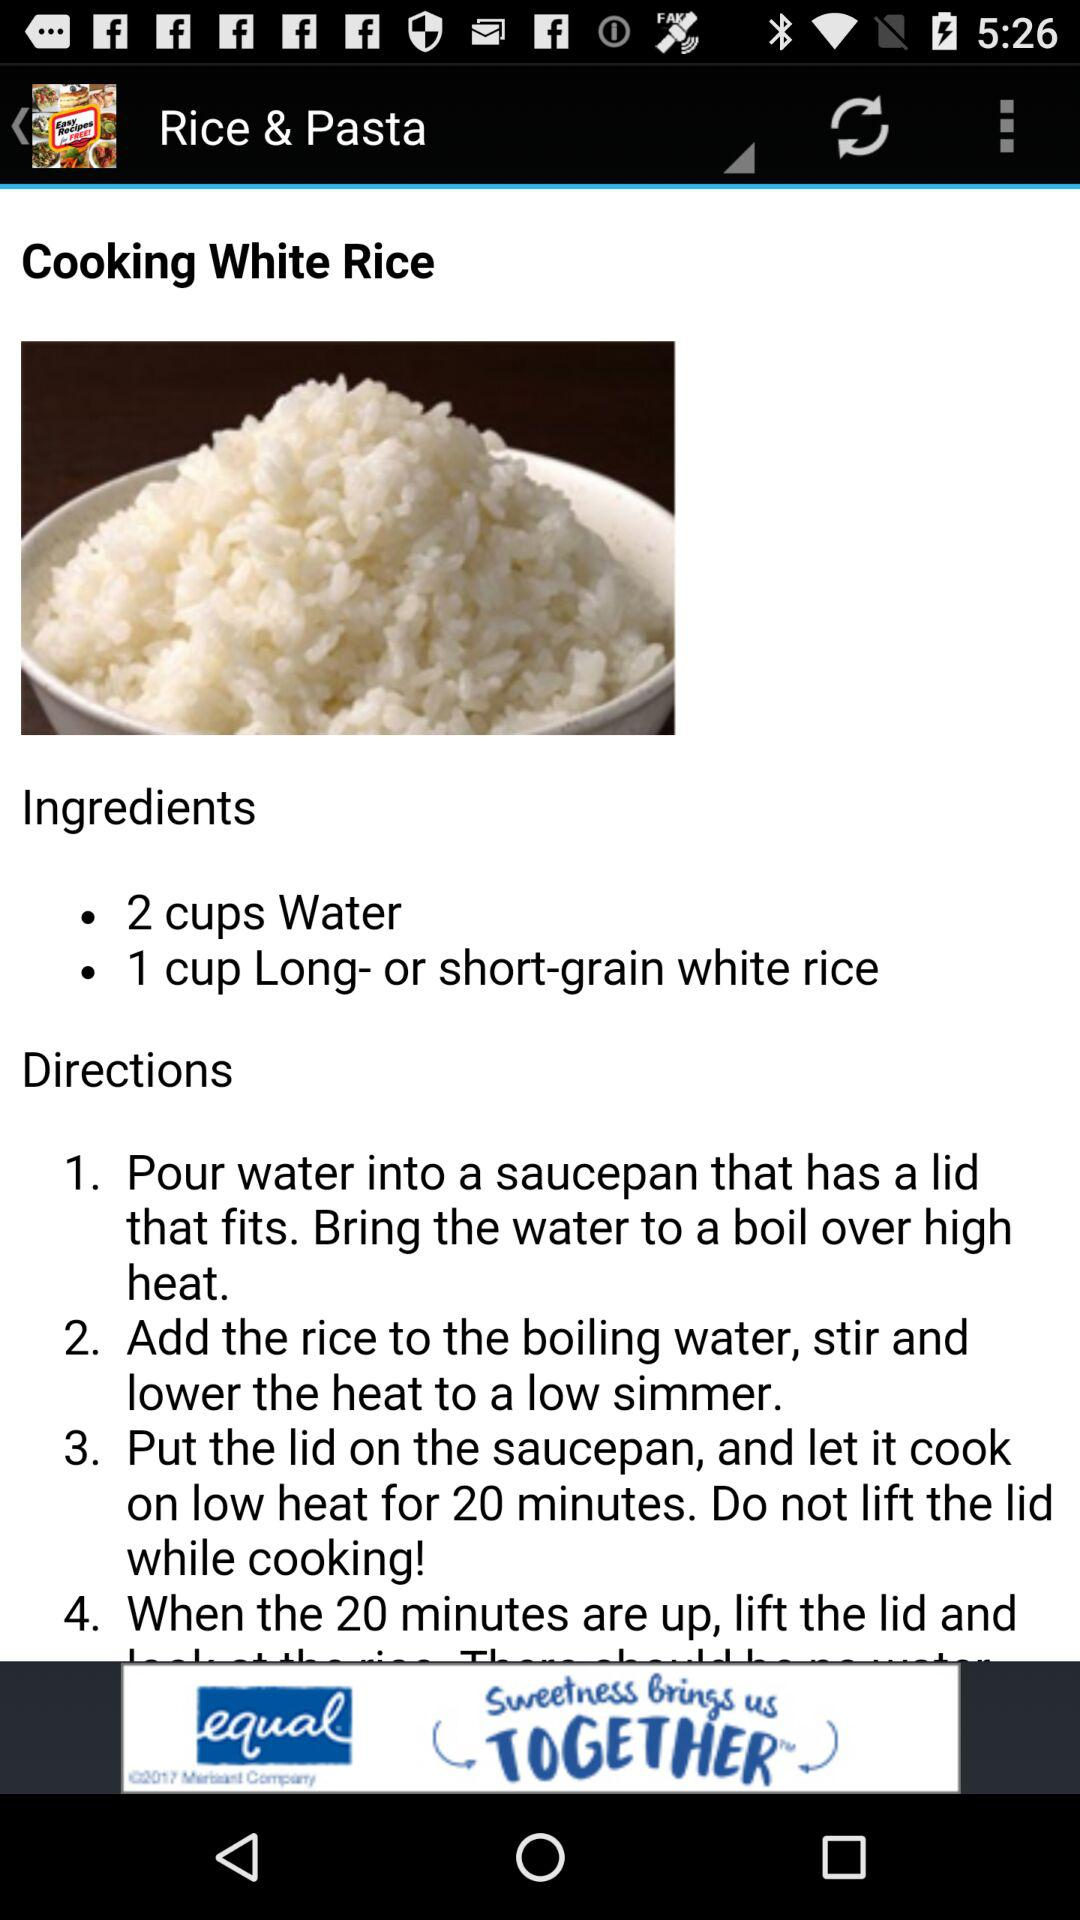For how many minutes was the recipe cooked on low heat? The recipe was cooked on low heat for 20 minutes. 